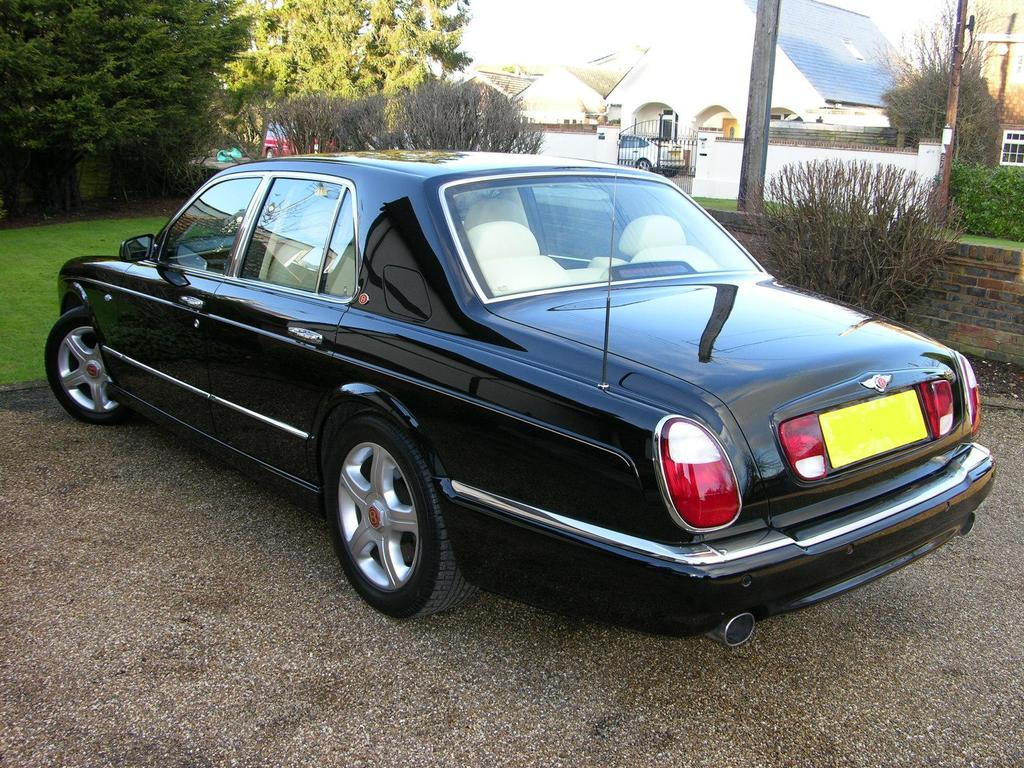What types of vehicles can be seen in the image? There are vehicles of different colors in the image. What natural elements are present in the image? There is sand, plants, trees, and grass visible in the image. What man-made structures can be seen in the image? There appears to be a building in the image. What other objects can be seen in the image? There are poles visible in the image. What type of calculator is being used by the actor in the image? There is no actor or calculator present in the image. Can you describe the swing that is visible in the image? There is no swing present in the image. 